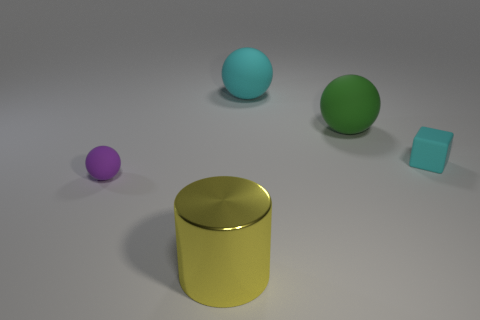What is the material of the big object that is the same color as the block?
Provide a short and direct response. Rubber. What size is the object that is the same color as the tiny block?
Provide a short and direct response. Large. The small block is what color?
Provide a short and direct response. Cyan. What number of metal objects are cylinders or purple objects?
Your answer should be very brief. 1. There is a large green rubber sphere to the right of the cyan rubber object that is behind the cyan rubber cube; is there a sphere that is behind it?
Provide a short and direct response. Yes. There is a cube that is the same material as the big green object; what is its size?
Offer a terse response. Small. Are there any rubber things to the left of the tiny cube?
Your answer should be compact. Yes. There is a matte sphere right of the big cyan object; are there any large yellow shiny things to the left of it?
Provide a succinct answer. Yes. Does the cyan object that is in front of the large green ball have the same size as the matte sphere that is behind the green matte object?
Give a very brief answer. No. How many tiny objects are either cyan matte balls or green balls?
Provide a short and direct response. 0. 